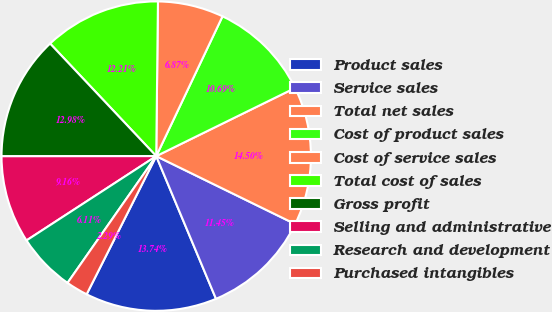Convert chart. <chart><loc_0><loc_0><loc_500><loc_500><pie_chart><fcel>Product sales<fcel>Service sales<fcel>Total net sales<fcel>Cost of product sales<fcel>Cost of service sales<fcel>Total cost of sales<fcel>Gross profit<fcel>Selling and administrative<fcel>Research and development<fcel>Purchased intangibles<nl><fcel>13.74%<fcel>11.45%<fcel>14.5%<fcel>10.69%<fcel>6.87%<fcel>12.21%<fcel>12.98%<fcel>9.16%<fcel>6.11%<fcel>2.29%<nl></chart> 